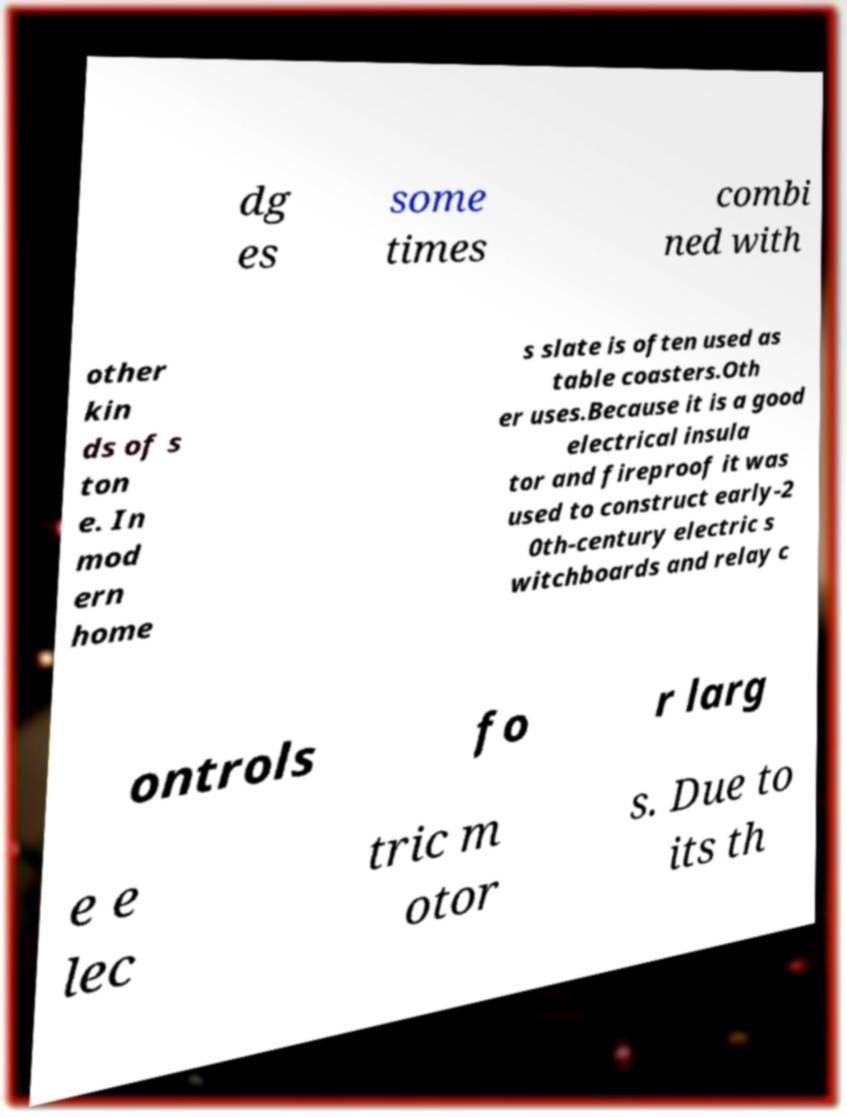Could you extract and type out the text from this image? dg es some times combi ned with other kin ds of s ton e. In mod ern home s slate is often used as table coasters.Oth er uses.Because it is a good electrical insula tor and fireproof it was used to construct early-2 0th-century electric s witchboards and relay c ontrols fo r larg e e lec tric m otor s. Due to its th 